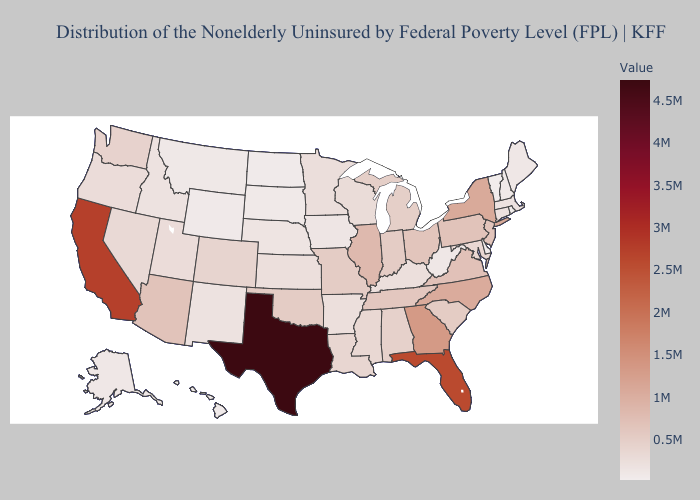Does New York have the lowest value in the Northeast?
Short answer required. No. Does Texas have the highest value in the USA?
Give a very brief answer. Yes. Does California have the highest value in the West?
Keep it brief. Yes. 